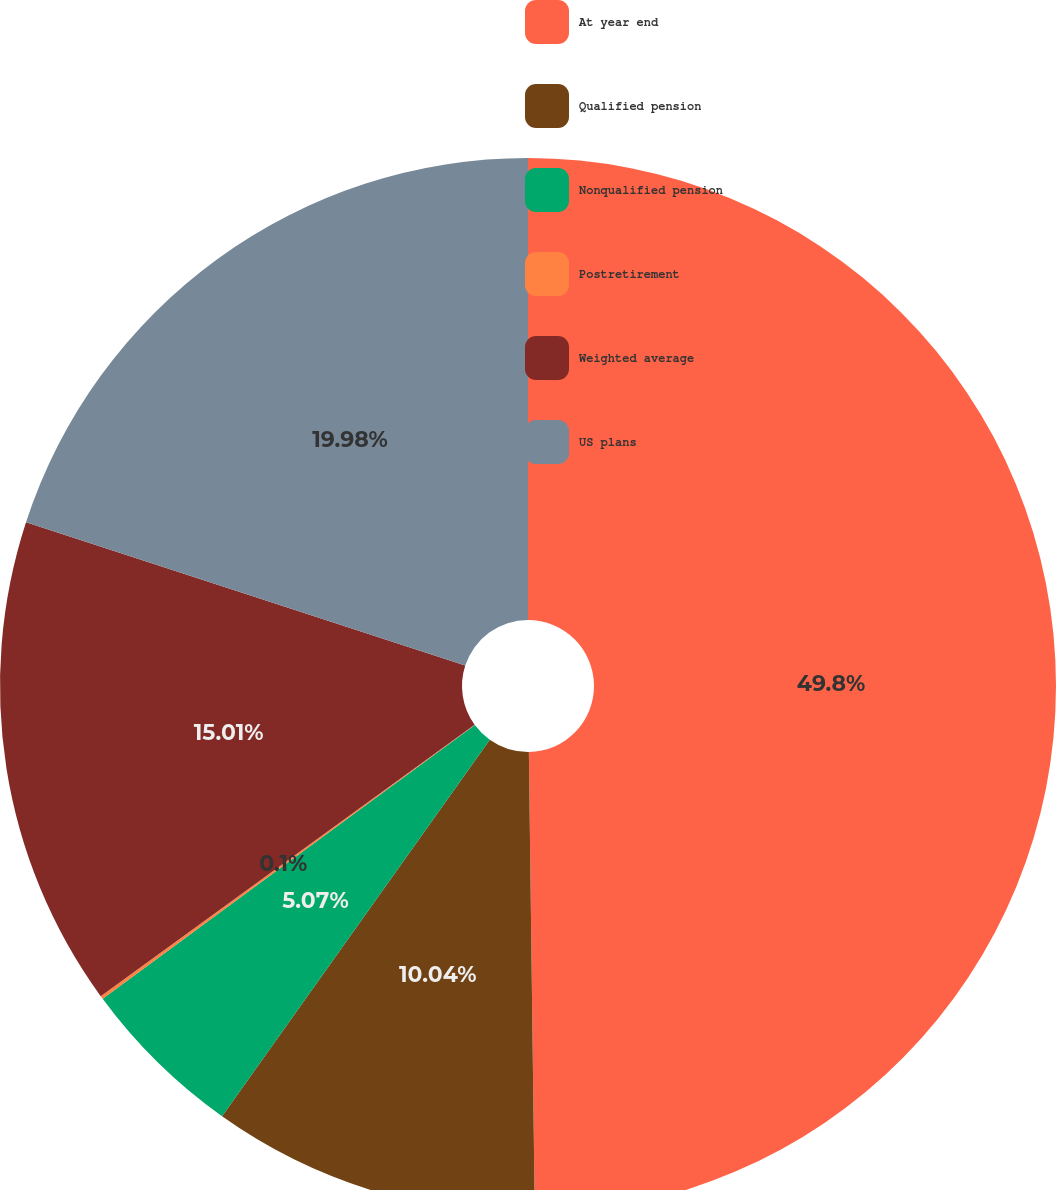<chart> <loc_0><loc_0><loc_500><loc_500><pie_chart><fcel>At year end<fcel>Qualified pension<fcel>Nonqualified pension<fcel>Postretirement<fcel>Weighted average<fcel>US plans<nl><fcel>49.79%<fcel>10.04%<fcel>5.07%<fcel>0.1%<fcel>15.01%<fcel>19.98%<nl></chart> 